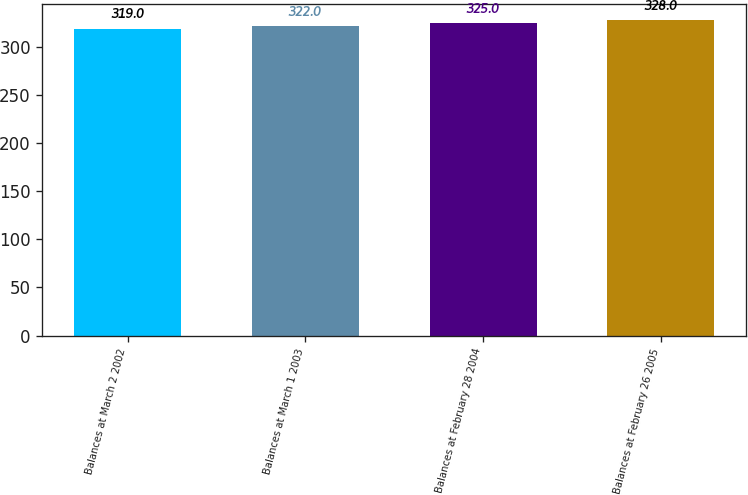Convert chart. <chart><loc_0><loc_0><loc_500><loc_500><bar_chart><fcel>Balances at March 2 2002<fcel>Balances at March 1 2003<fcel>Balances at February 28 2004<fcel>Balances at February 26 2005<nl><fcel>319<fcel>322<fcel>325<fcel>328<nl></chart> 